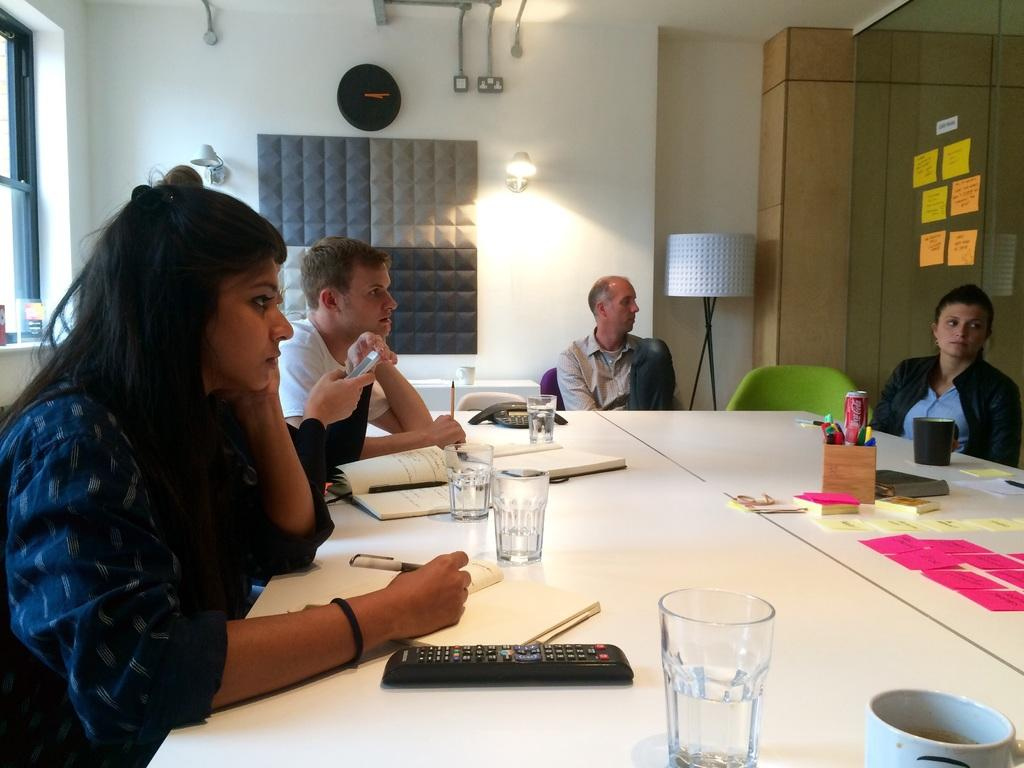What is the main subject of the image? The main subject of the image is a group of people. What are the people in the image doing? The people are seated on chairs. What objects can be seen on the table in the image? There are glasses and books on the table. How many managers are present in the image? There is no mention of a manager in the image, so it cannot be determined how many are present. 